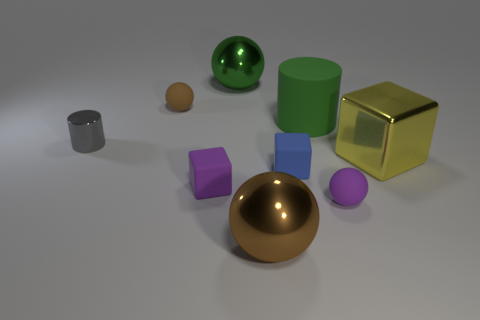What number of small things are yellow blocks or brown things?
Provide a short and direct response. 1. What number of metal objects are to the left of the small brown matte thing and to the right of the brown metal object?
Provide a succinct answer. 0. Is the number of small cyan matte blocks greater than the number of metallic blocks?
Provide a short and direct response. No. What number of other things are there of the same shape as the green metallic object?
Your answer should be very brief. 3. Do the large cylinder and the shiny cylinder have the same color?
Offer a terse response. No. There is a object that is behind the small purple block and on the right side of the large matte thing; what is its material?
Keep it short and to the point. Metal. The green sphere has what size?
Offer a very short reply. Large. What number of large balls are behind the blue object that is to the right of the metal sphere that is behind the yellow metallic cube?
Ensure brevity in your answer.  1. There is a purple thing that is left of the cylinder right of the gray thing; what shape is it?
Keep it short and to the point. Cube. There is a green object that is the same shape as the tiny gray object; what is its size?
Your answer should be very brief. Large. 